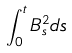Convert formula to latex. <formula><loc_0><loc_0><loc_500><loc_500>\int _ { 0 } ^ { t } B _ { s } ^ { 2 } d s</formula> 